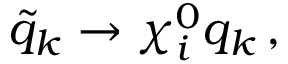<formula> <loc_0><loc_0><loc_500><loc_500>\tilde { q } _ { k } \rightarrow \chi _ { i } ^ { 0 } q _ { k } \, ,</formula> 